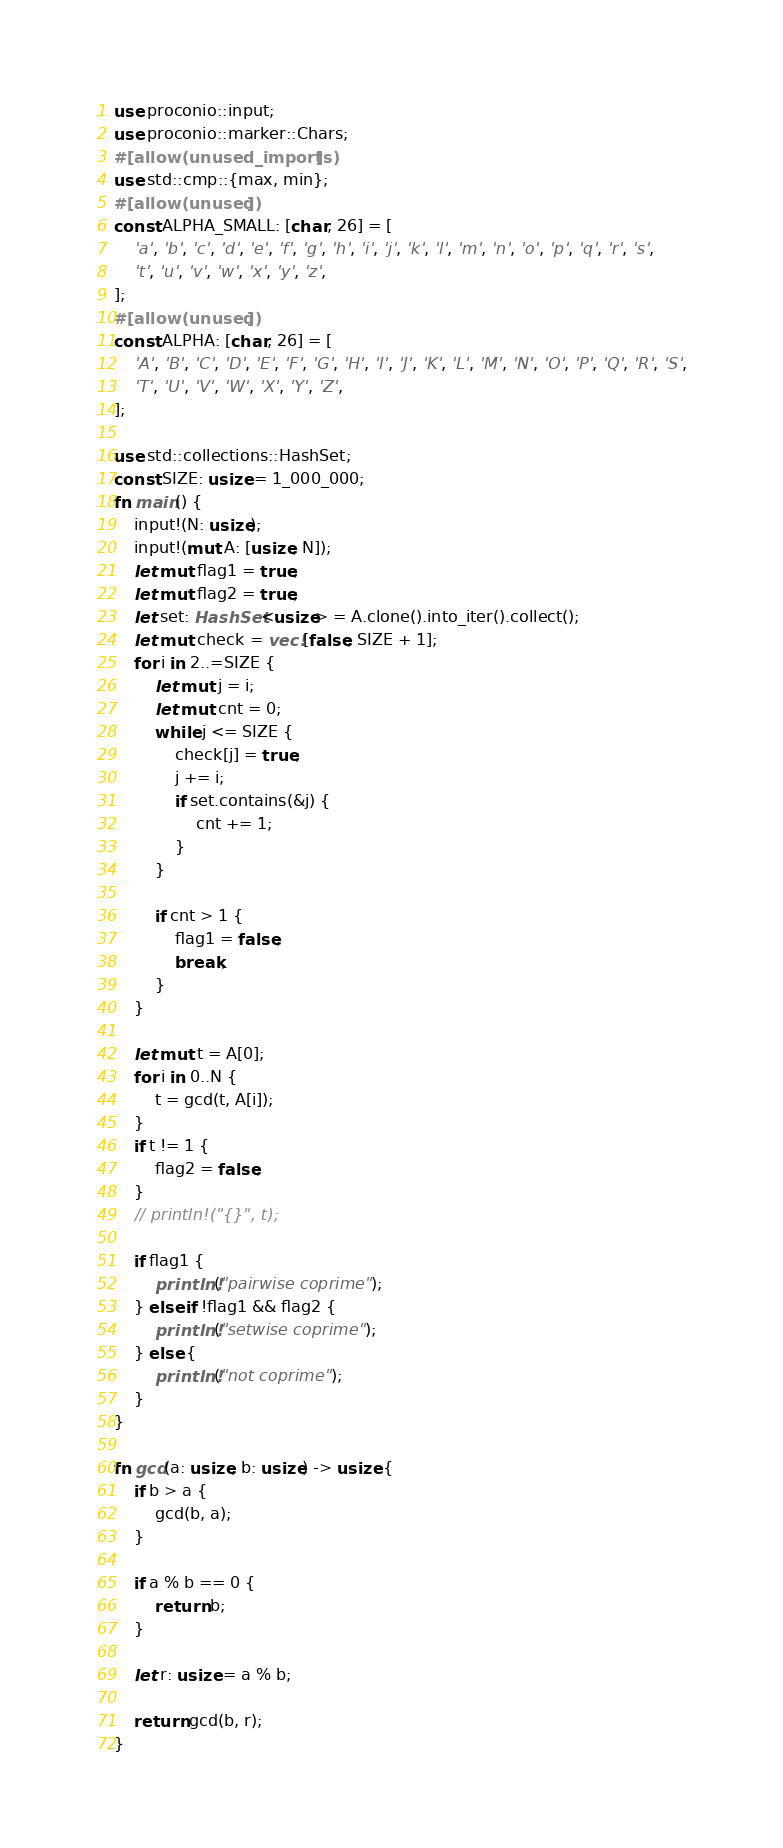Convert code to text. <code><loc_0><loc_0><loc_500><loc_500><_Rust_>use proconio::input;
use proconio::marker::Chars;
#[allow(unused_imports)]
use std::cmp::{max, min};
#[allow(unused)]
const ALPHA_SMALL: [char; 26] = [
    'a', 'b', 'c', 'd', 'e', 'f', 'g', 'h', 'i', 'j', 'k', 'l', 'm', 'n', 'o', 'p', 'q', 'r', 's',
    't', 'u', 'v', 'w', 'x', 'y', 'z',
];
#[allow(unused)]
const ALPHA: [char; 26] = [
    'A', 'B', 'C', 'D', 'E', 'F', 'G', 'H', 'I', 'J', 'K', 'L', 'M', 'N', 'O', 'P', 'Q', 'R', 'S',
    'T', 'U', 'V', 'W', 'X', 'Y', 'Z',
];

use std::collections::HashSet;
const SIZE: usize = 1_000_000;
fn main() {
    input!(N: usize);
    input!(mut A: [usize; N]);
    let mut flag1 = true;
    let mut flag2 = true;
    let set: HashSet<usize> = A.clone().into_iter().collect();
    let mut check = vec![false; SIZE + 1];
    for i in 2..=SIZE {
        let mut j = i;
        let mut cnt = 0;
        while j <= SIZE {
            check[j] = true;
            j += i;
            if set.contains(&j) {
                cnt += 1;
            }
        }

        if cnt > 1 {
            flag1 = false;
            break;
        }
    }

    let mut t = A[0];
    for i in 0..N {
        t = gcd(t, A[i]);
    }
    if t != 1 {
        flag2 = false;
    }
    // println!("{}", t);

    if flag1 {
        println!("pairwise coprime");
    } else if !flag1 && flag2 {
        println!("setwise coprime");
    } else {
        println!("not coprime");
    }
}

fn gcd(a: usize, b: usize) -> usize {
    if b > a {
        gcd(b, a);
    }

    if a % b == 0 {
        return b;
    }

    let r: usize = a % b;

    return gcd(b, r);
}
</code> 